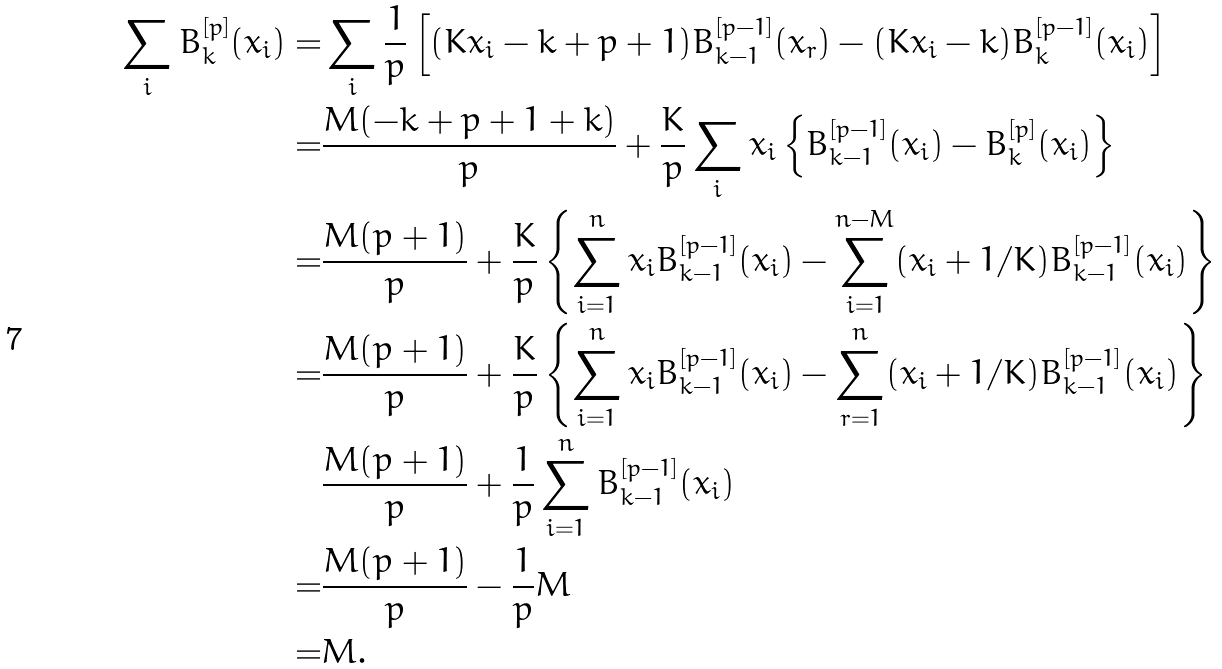Convert formula to latex. <formula><loc_0><loc_0><loc_500><loc_500>\sum _ { i } B ^ { [ p ] } _ { k } ( x _ { i } ) = & \sum _ { i } \frac { 1 } { p } \left [ ( K x _ { i } - k + p + 1 ) B _ { k - 1 } ^ { [ p - 1 ] } ( x _ { r } ) - ( K x _ { i } - k ) B _ { k } ^ { [ p - 1 ] } ( x _ { i } ) \right ] \\ = & \frac { M ( - k + p + 1 + k ) } { p } + \frac { K } { p } \sum _ { i } x _ { i } \left \{ B _ { k - 1 } ^ { [ p - 1 ] } ( x _ { i } ) - B _ { k } ^ { [ p ] } ( x _ { i } ) \right \} \\ = & \frac { M ( p + 1 ) } { p } + \frac { K } { p } \left \{ \sum _ { i = 1 } ^ { n } x _ { i } B _ { k - 1 } ^ { [ p - 1 ] } ( x _ { i } ) - \sum _ { i = 1 } ^ { n - M } ( x _ { i } + 1 / K ) B _ { k - 1 } ^ { [ p - 1 ] } ( x _ { i } ) \right \} \\ = & \frac { M ( p + 1 ) } { p } + \frac { K } { p } \left \{ \sum _ { i = 1 } ^ { n } x _ { i } B _ { k - 1 } ^ { [ p - 1 ] } ( x _ { i } ) - \sum _ { r = 1 } ^ { n } ( x _ { i } + 1 / K ) B _ { k - 1 } ^ { [ p - 1 ] } ( x _ { i } ) \right \} \\ & \frac { M ( p + 1 ) } { p } + \frac { 1 } { p } \sum _ { i = 1 } ^ { n } B _ { k - 1 } ^ { [ p - 1 ] } ( x _ { i } ) \\ = & \frac { M ( p + 1 ) } { p } - \frac { 1 } { p } M \\ = & M .</formula> 